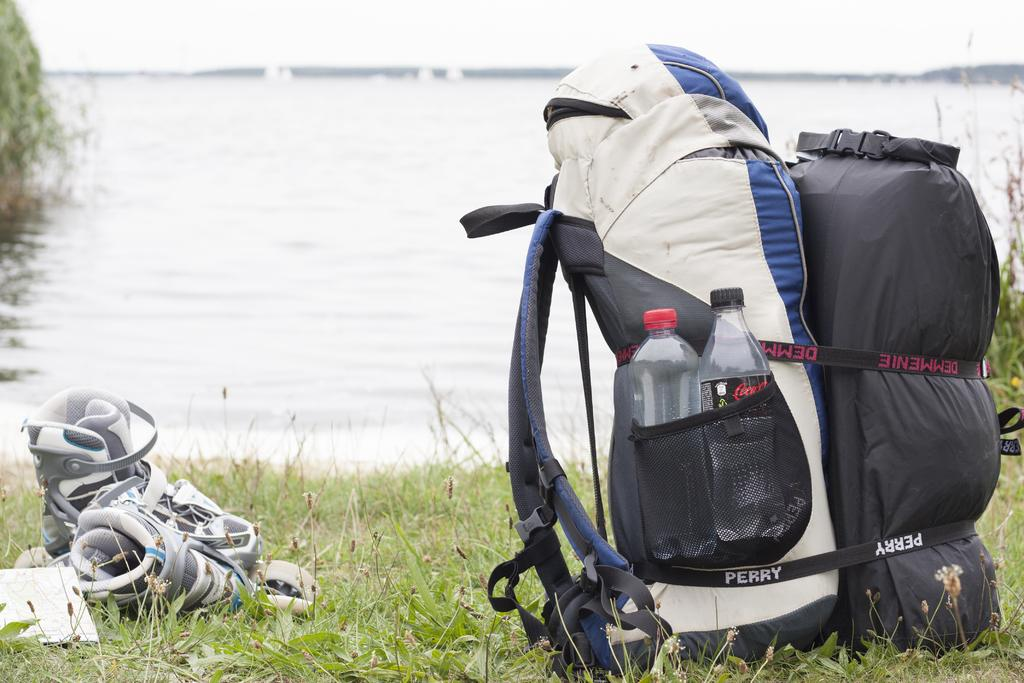<image>
Give a short and clear explanation of the subsequent image. A large back strapped to another bag with a Perry strap. 